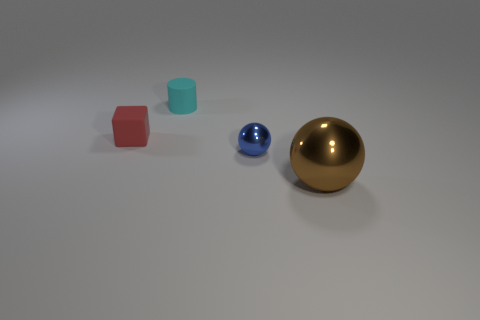What shape is the blue thing?
Ensure brevity in your answer.  Sphere. How many other big brown metal objects are the same shape as the brown metallic thing?
Your response must be concise. 0. What number of rubber things are on the left side of the matte cylinder and on the right side of the red matte block?
Keep it short and to the point. 0. The small metallic thing has what color?
Ensure brevity in your answer.  Blue. Are there any other brown balls that have the same material as the tiny ball?
Make the answer very short. Yes. There is a matte thing in front of the small rubber object that is behind the red object; are there any small blue objects to the right of it?
Provide a short and direct response. Yes. There is a matte cylinder; are there any cyan rubber things behind it?
Your answer should be very brief. No. What number of tiny objects are either red matte objects or metal spheres?
Provide a short and direct response. 2. Is the material of the sphere left of the large brown shiny object the same as the small cyan object?
Make the answer very short. No. There is a metallic thing that is to the right of the metallic object on the left side of the metal sphere right of the blue ball; what is its shape?
Provide a succinct answer. Sphere. 